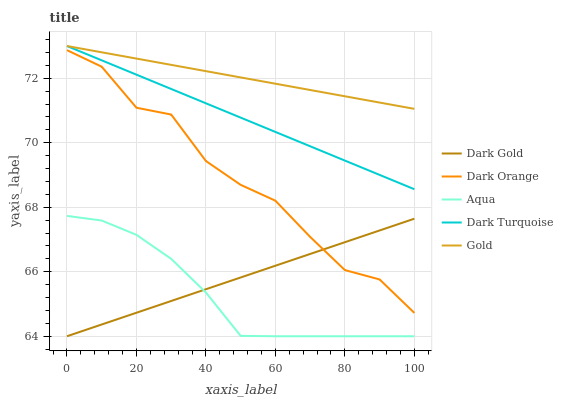Does Aqua have the minimum area under the curve?
Answer yes or no. Yes. Does Gold have the maximum area under the curve?
Answer yes or no. Yes. Does Gold have the minimum area under the curve?
Answer yes or no. No. Does Aqua have the maximum area under the curve?
Answer yes or no. No. Is Gold the smoothest?
Answer yes or no. Yes. Is Dark Orange the roughest?
Answer yes or no. Yes. Is Aqua the smoothest?
Answer yes or no. No. Is Aqua the roughest?
Answer yes or no. No. Does Aqua have the lowest value?
Answer yes or no. Yes. Does Gold have the lowest value?
Answer yes or no. No. Does Dark Turquoise have the highest value?
Answer yes or no. Yes. Does Aqua have the highest value?
Answer yes or no. No. Is Aqua less than Dark Turquoise?
Answer yes or no. Yes. Is Dark Orange greater than Aqua?
Answer yes or no. Yes. Does Dark Gold intersect Dark Orange?
Answer yes or no. Yes. Is Dark Gold less than Dark Orange?
Answer yes or no. No. Is Dark Gold greater than Dark Orange?
Answer yes or no. No. Does Aqua intersect Dark Turquoise?
Answer yes or no. No. 